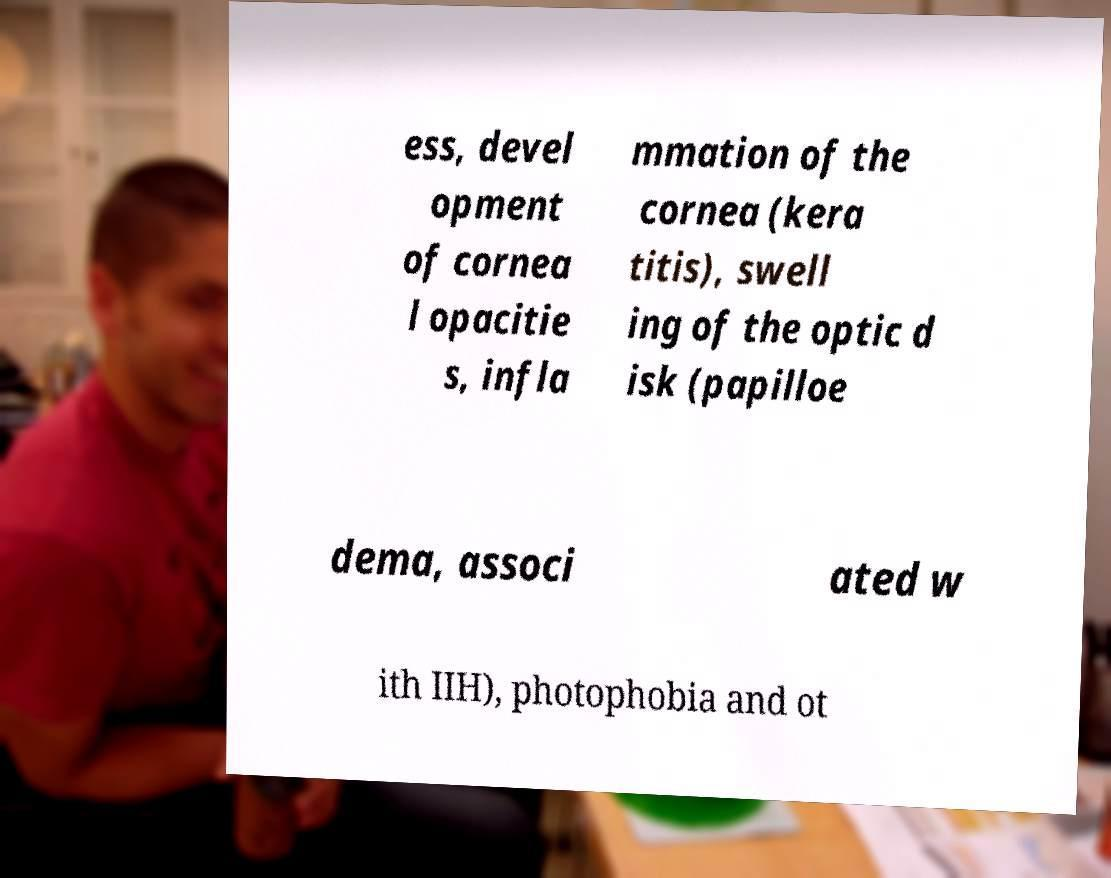What messages or text are displayed in this image? I need them in a readable, typed format. ess, devel opment of cornea l opacitie s, infla mmation of the cornea (kera titis), swell ing of the optic d isk (papilloe dema, associ ated w ith IIH), photophobia and ot 